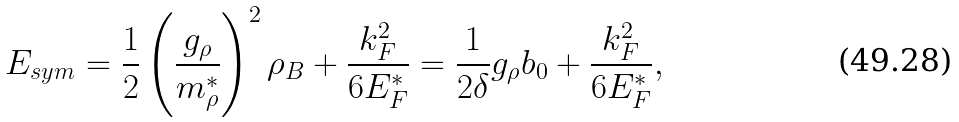Convert formula to latex. <formula><loc_0><loc_0><loc_500><loc_500>E _ { s y m } = \frac { 1 } { 2 } \left ( \frac { g _ { \rho } } { m _ { \rho } ^ { * } } \right ) ^ { 2 } \rho _ { B } + \frac { k _ { F } ^ { 2 } } { 6 E _ { F } ^ { * } } = \frac { 1 } { 2 \delta } g _ { \rho } b _ { 0 } + \frac { k _ { F } ^ { 2 } } { 6 E _ { F } ^ { * } } ,</formula> 